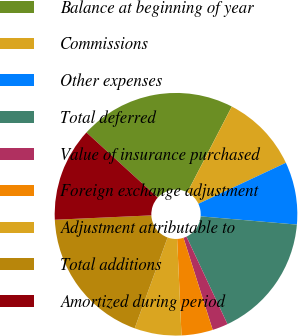Convert chart. <chart><loc_0><loc_0><loc_500><loc_500><pie_chart><fcel>Balance at beginning of year<fcel>Commissions<fcel>Other expenses<fcel>Total deferred<fcel>Value of insurance purchased<fcel>Foreign exchange adjustment<fcel>Adjustment attributable to<fcel>Total additions<fcel>Amortized during period<nl><fcel>20.83%<fcel>10.42%<fcel>8.33%<fcel>16.67%<fcel>2.08%<fcel>4.17%<fcel>6.25%<fcel>18.75%<fcel>12.5%<nl></chart> 